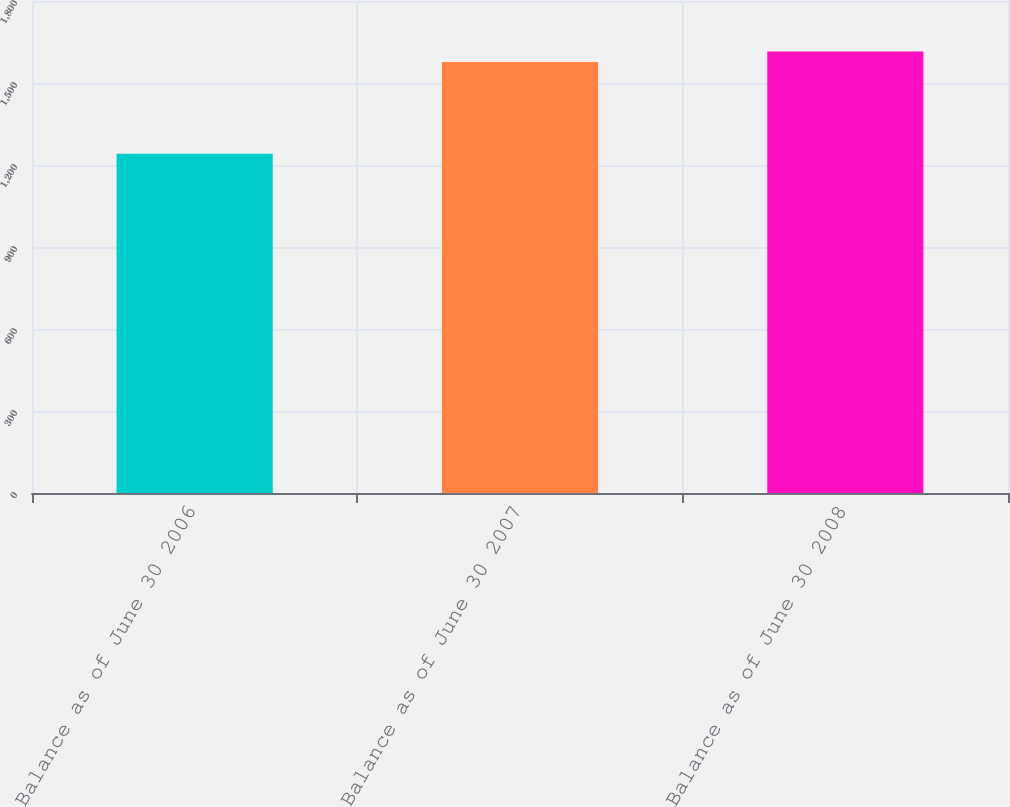Convert chart. <chart><loc_0><loc_0><loc_500><loc_500><bar_chart><fcel>Balance as of June 30 2006<fcel>Balance as of June 30 2007<fcel>Balance as of June 30 2008<nl><fcel>1241.4<fcel>1576.6<fcel>1615.7<nl></chart> 